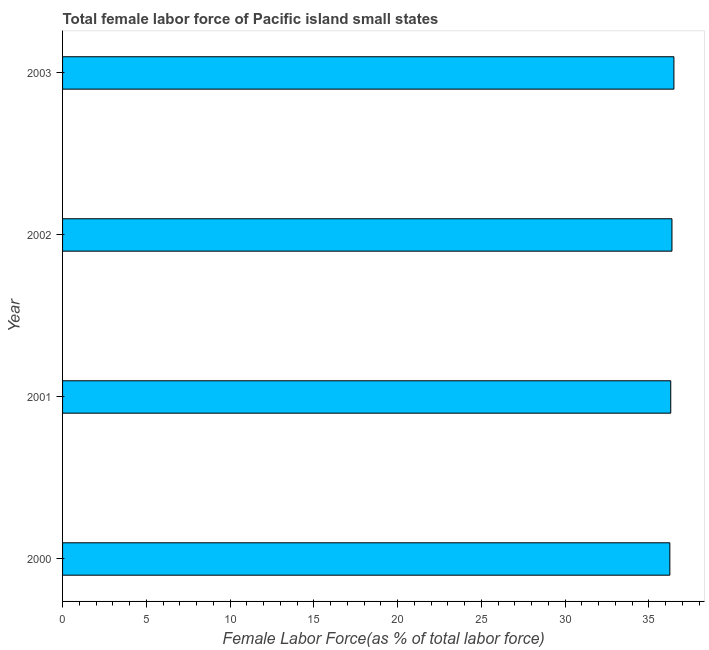Does the graph contain grids?
Offer a terse response. No. What is the title of the graph?
Your answer should be very brief. Total female labor force of Pacific island small states. What is the label or title of the X-axis?
Your answer should be compact. Female Labor Force(as % of total labor force). What is the label or title of the Y-axis?
Keep it short and to the point. Year. What is the total female labor force in 2003?
Make the answer very short. 36.5. Across all years, what is the maximum total female labor force?
Your answer should be compact. 36.5. Across all years, what is the minimum total female labor force?
Provide a succinct answer. 36.26. What is the sum of the total female labor force?
Provide a succinct answer. 145.46. What is the difference between the total female labor force in 2000 and 2003?
Your response must be concise. -0.24. What is the average total female labor force per year?
Make the answer very short. 36.36. What is the median total female labor force?
Make the answer very short. 36.35. What is the ratio of the total female labor force in 2001 to that in 2003?
Your response must be concise. 0.99. Is the total female labor force in 2001 less than that in 2002?
Your answer should be compact. Yes. What is the difference between the highest and the second highest total female labor force?
Offer a terse response. 0.12. Is the sum of the total female labor force in 2001 and 2002 greater than the maximum total female labor force across all years?
Provide a succinct answer. Yes. What is the difference between the highest and the lowest total female labor force?
Give a very brief answer. 0.24. Are all the bars in the graph horizontal?
Your answer should be compact. Yes. What is the Female Labor Force(as % of total labor force) of 2000?
Your response must be concise. 36.26. What is the Female Labor Force(as % of total labor force) in 2001?
Provide a succinct answer. 36.31. What is the Female Labor Force(as % of total labor force) in 2002?
Make the answer very short. 36.38. What is the Female Labor Force(as % of total labor force) in 2003?
Ensure brevity in your answer.  36.5. What is the difference between the Female Labor Force(as % of total labor force) in 2000 and 2001?
Provide a short and direct response. -0.05. What is the difference between the Female Labor Force(as % of total labor force) in 2000 and 2002?
Offer a terse response. -0.13. What is the difference between the Female Labor Force(as % of total labor force) in 2000 and 2003?
Provide a short and direct response. -0.24. What is the difference between the Female Labor Force(as % of total labor force) in 2001 and 2002?
Make the answer very short. -0.07. What is the difference between the Female Labor Force(as % of total labor force) in 2001 and 2003?
Make the answer very short. -0.19. What is the difference between the Female Labor Force(as % of total labor force) in 2002 and 2003?
Offer a terse response. -0.12. What is the ratio of the Female Labor Force(as % of total labor force) in 2002 to that in 2003?
Offer a terse response. 1. 